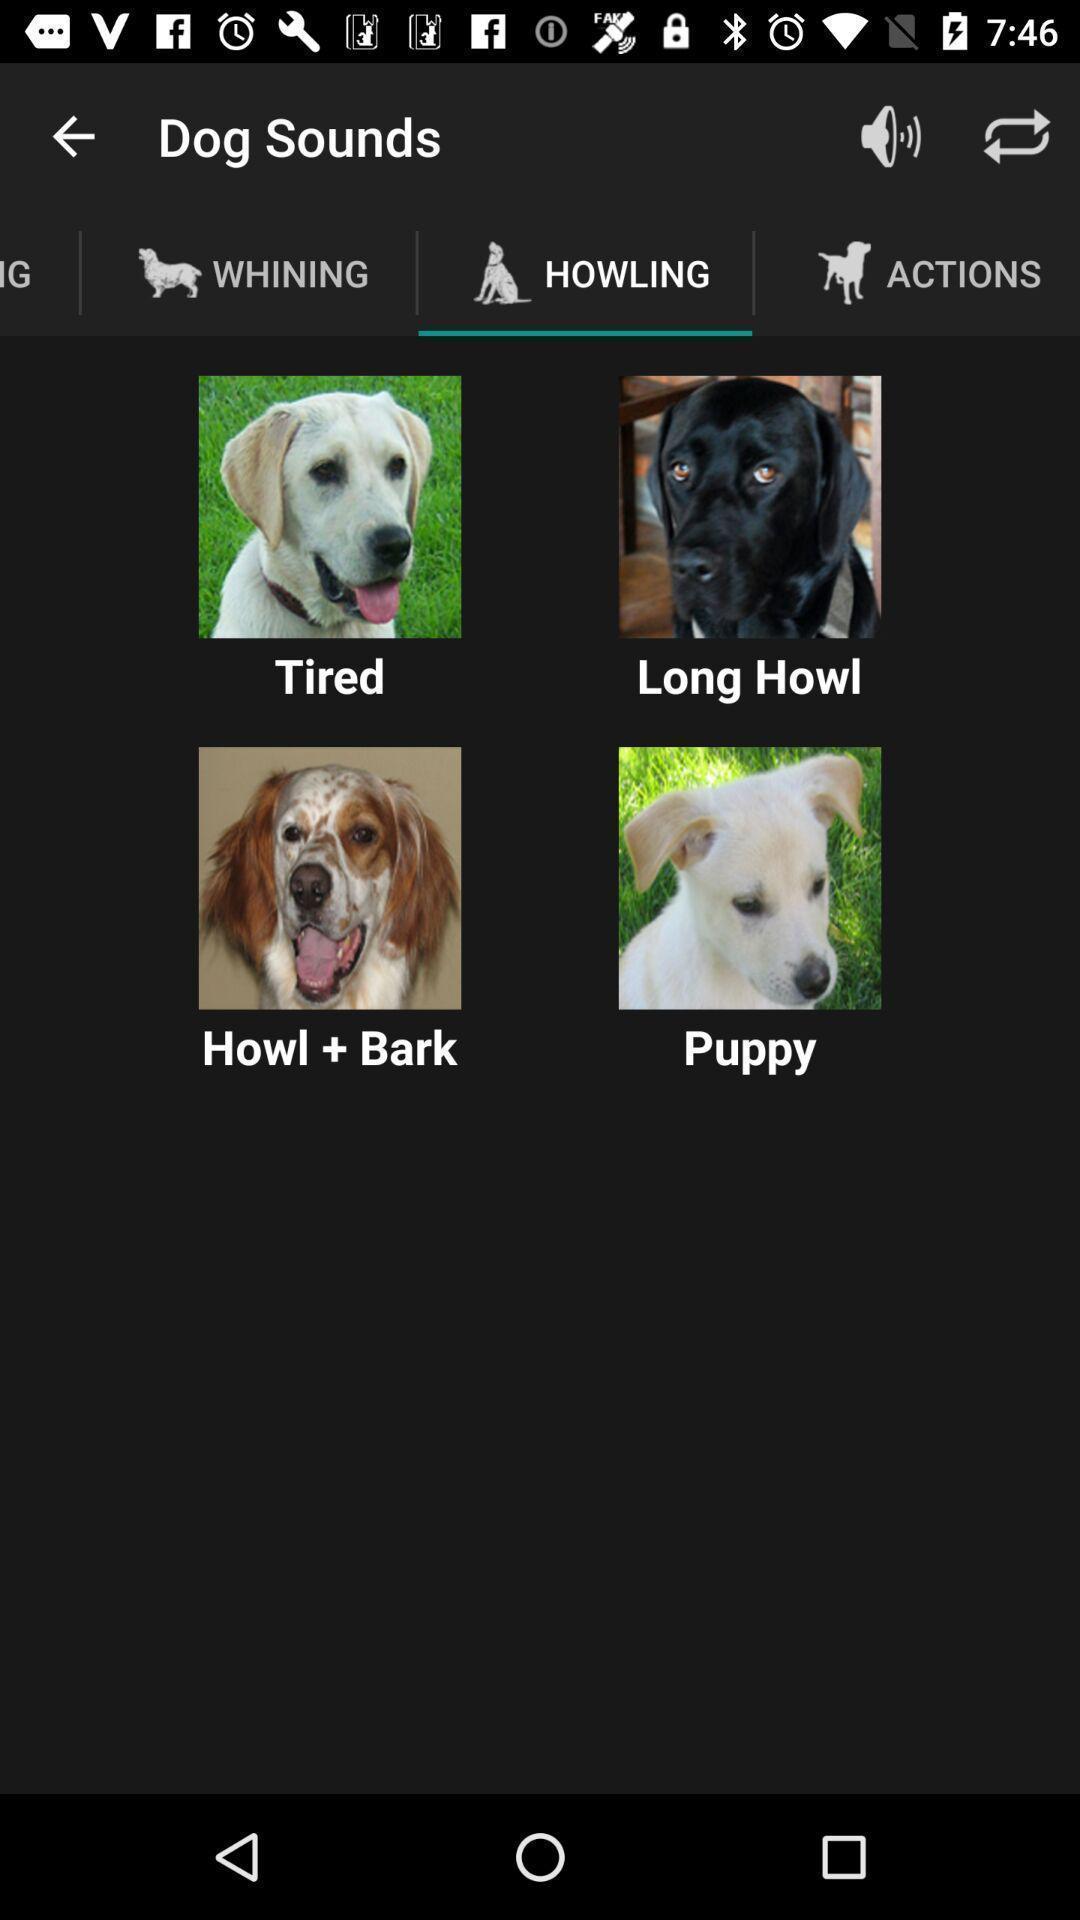Summarize the main components in this picture. Screen displaying howling page. 